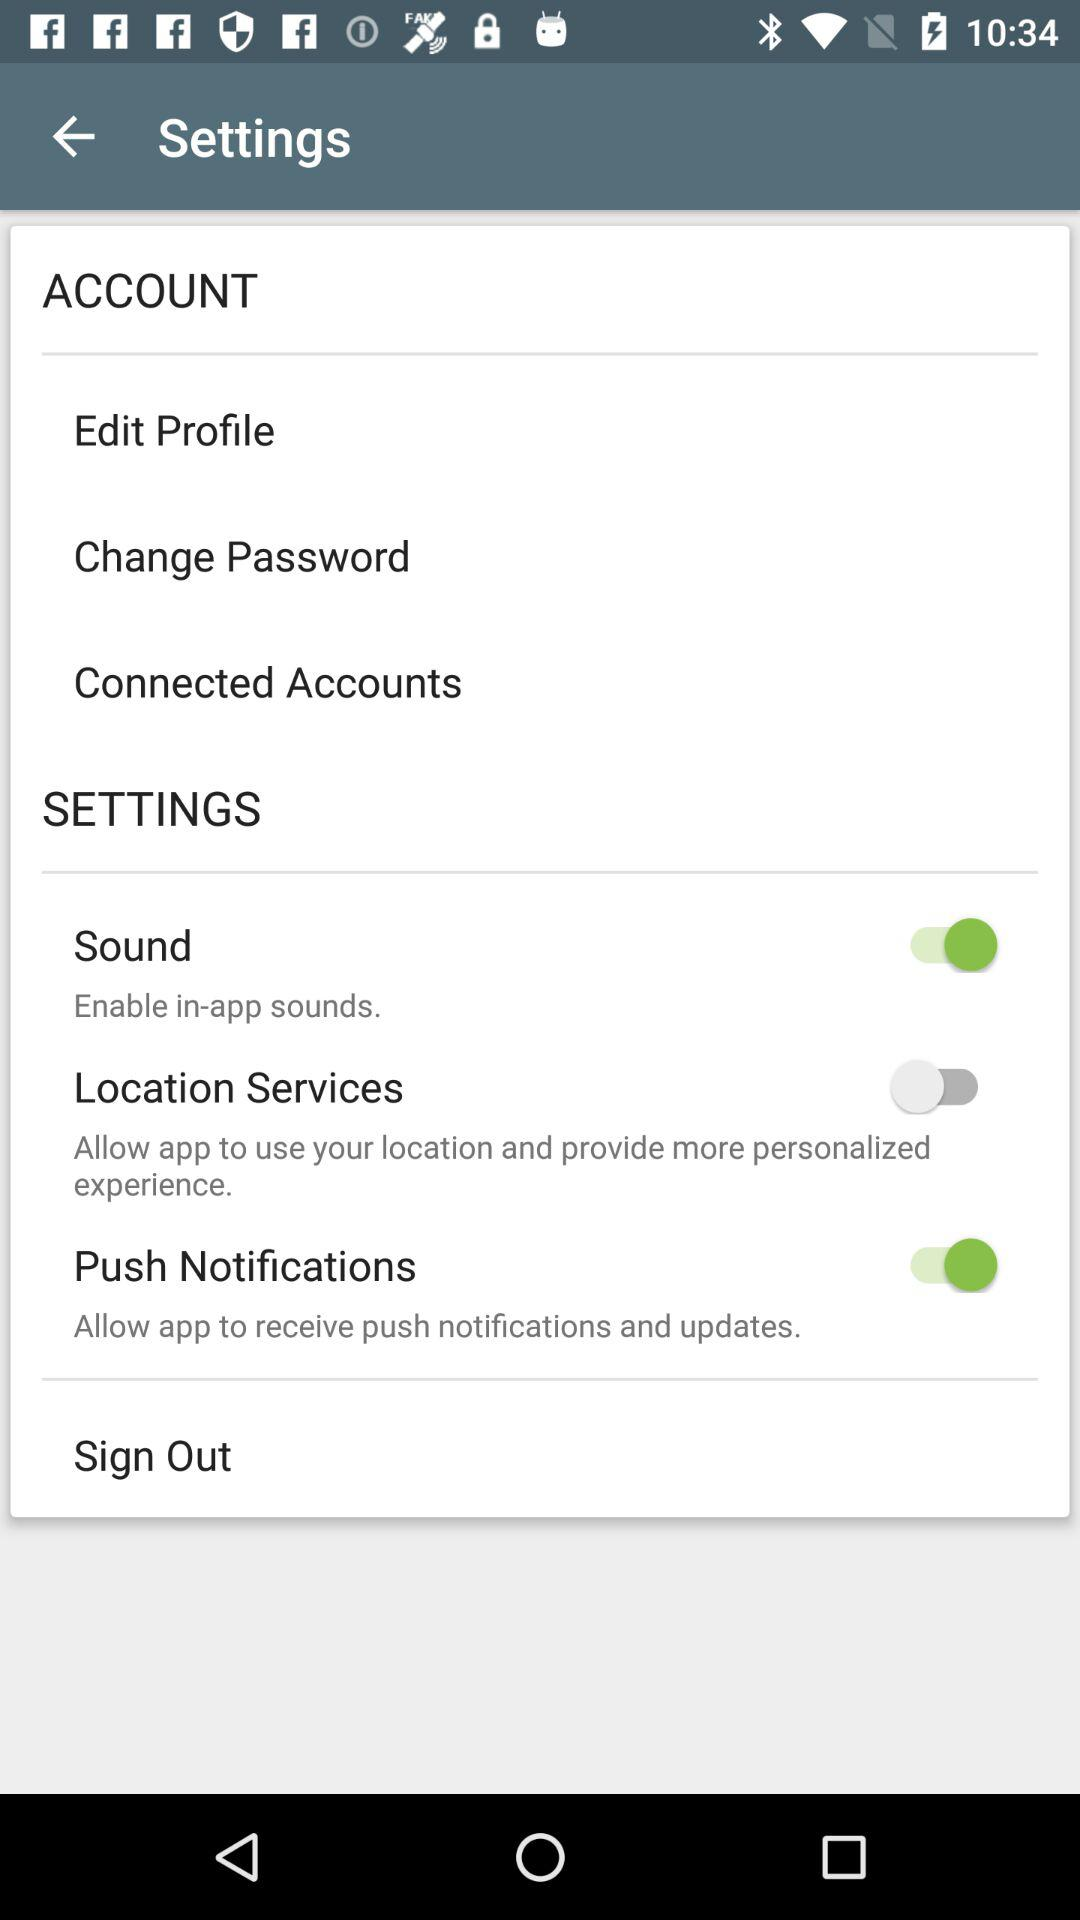How many items in the settings menu have a switch?
Answer the question using a single word or phrase. 3 